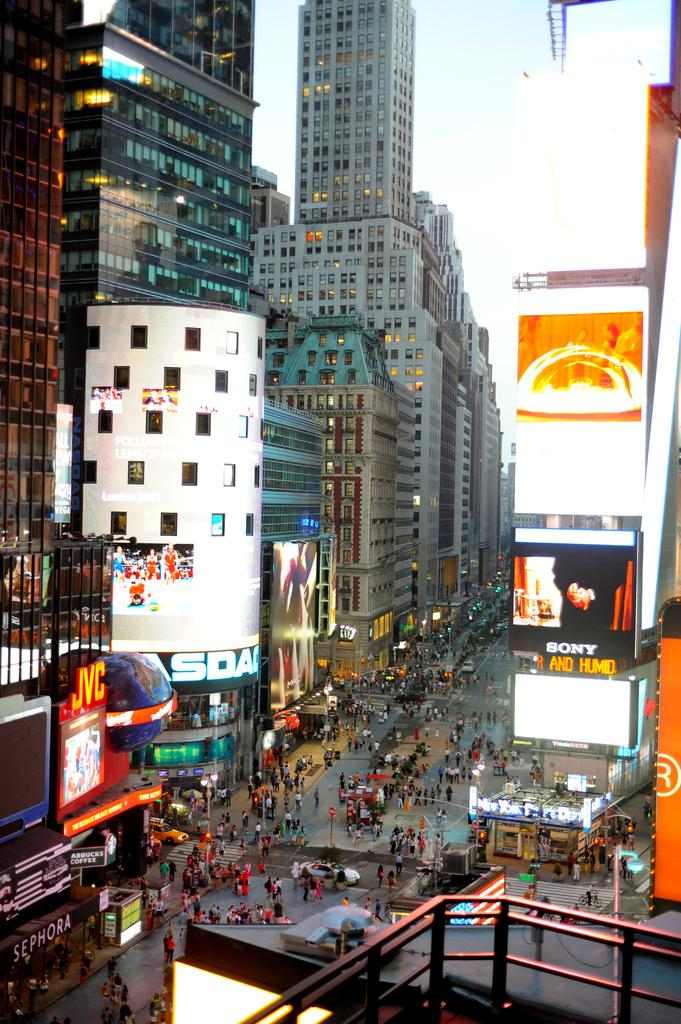What type of structures can be seen in the image? There are buildings in the image. What architectural features can be observed on the buildings? There are windows visible on the buildings. What type of signage is present in the image? There are posters in the image. What mode of transportation can be seen in the image? There are vehicles in the image. Are there any human figures present in the image? Yes, there are people in the image. What type of lighting is present in the image? There are lights in the image. What type of signage contains text in the image? There are boards with text in the image. What part of the natural environment is visible in the image? The sky is visible in the image. Where is the flame coming from in the image? There is no flame present in the image. What type of salt is being used to season the food in the image? There is no food or salt present in the image. 